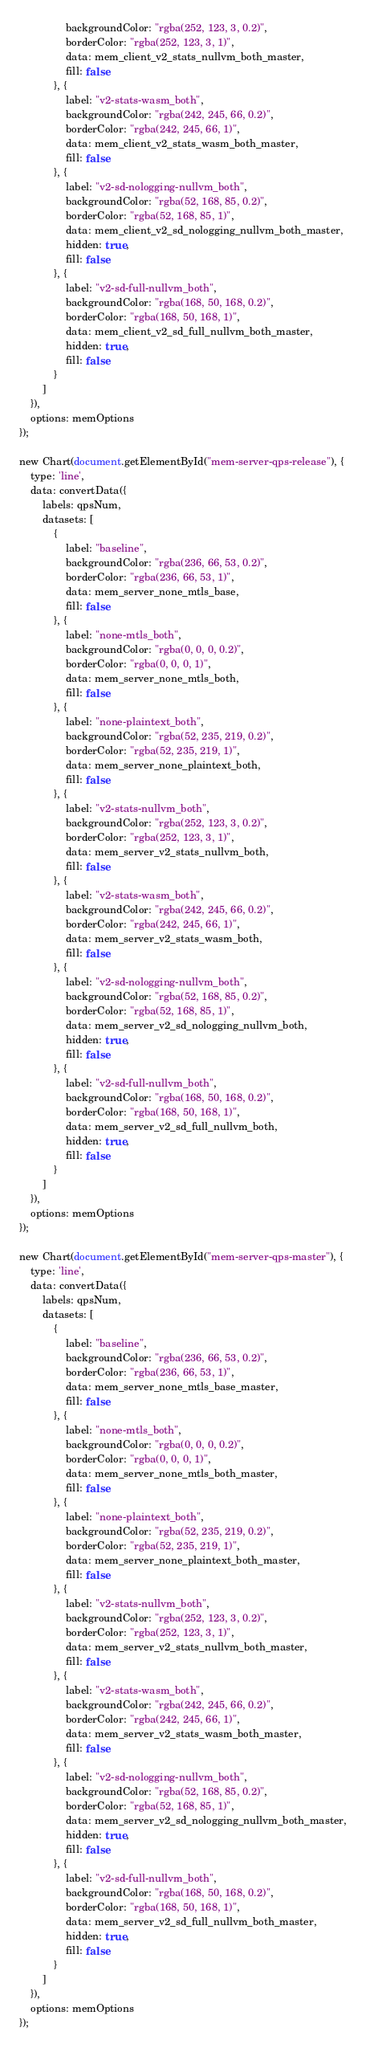<code> <loc_0><loc_0><loc_500><loc_500><_JavaScript_>                backgroundColor: "rgba(252, 123, 3, 0.2)",
                borderColor: "rgba(252, 123, 3, 1)",
                data: mem_client_v2_stats_nullvm_both_master,
                fill: false
            }, {
                label: "v2-stats-wasm_both",
                backgroundColor: "rgba(242, 245, 66, 0.2)",
                borderColor: "rgba(242, 245, 66, 1)",
                data: mem_client_v2_stats_wasm_both_master,
                fill: false
            }, {
                label: "v2-sd-nologging-nullvm_both",
                backgroundColor: "rgba(52, 168, 85, 0.2)",
                borderColor: "rgba(52, 168, 85, 1)",
                data: mem_client_v2_sd_nologging_nullvm_both_master,
                hidden: true,
                fill: false
            }, {
                label: "v2-sd-full-nullvm_both",
                backgroundColor: "rgba(168, 50, 168, 0.2)",
                borderColor: "rgba(168, 50, 168, 1)",
                data: mem_client_v2_sd_full_nullvm_both_master,
                hidden: true,
                fill: false
            }
        ]
    }),
    options: memOptions
});

new Chart(document.getElementById("mem-server-qps-release"), {
    type: 'line',
    data: convertData({
        labels: qpsNum,
        datasets: [
            {
                label: "baseline",
                backgroundColor: "rgba(236, 66, 53, 0.2)",
                borderColor: "rgba(236, 66, 53, 1)",
                data: mem_server_none_mtls_base,
                fill: false
            }, {
                label: "none-mtls_both",
                backgroundColor: "rgba(0, 0, 0, 0.2)",
                borderColor: "rgba(0, 0, 0, 1)",
                data: mem_server_none_mtls_both,
                fill: false
            }, {
                label: "none-plaintext_both",
                backgroundColor: "rgba(52, 235, 219, 0.2)",
                borderColor: "rgba(52, 235, 219, 1)",
                data: mem_server_none_plaintext_both,
                fill: false
            }, {
                label: "v2-stats-nullvm_both",
                backgroundColor: "rgba(252, 123, 3, 0.2)",
                borderColor: "rgba(252, 123, 3, 1)",
                data: mem_server_v2_stats_nullvm_both,
                fill: false
            }, {
                label: "v2-stats-wasm_both",
                backgroundColor: "rgba(242, 245, 66, 0.2)",
                borderColor: "rgba(242, 245, 66, 1)",
                data: mem_server_v2_stats_wasm_both,
                fill: false
            }, {
                label: "v2-sd-nologging-nullvm_both",
                backgroundColor: "rgba(52, 168, 85, 0.2)",
                borderColor: "rgba(52, 168, 85, 1)",
                data: mem_server_v2_sd_nologging_nullvm_both,
                hidden: true,
                fill: false
            }, {
                label: "v2-sd-full-nullvm_both",
                backgroundColor: "rgba(168, 50, 168, 0.2)",
                borderColor: "rgba(168, 50, 168, 1)",
                data: mem_server_v2_sd_full_nullvm_both,
                hidden: true,
                fill: false
            }
        ]
    }),
    options: memOptions
});

new Chart(document.getElementById("mem-server-qps-master"), {
    type: 'line',
    data: convertData({
        labels: qpsNum,
        datasets: [
            {
                label: "baseline",
                backgroundColor: "rgba(236, 66, 53, 0.2)",
                borderColor: "rgba(236, 66, 53, 1)",
                data: mem_server_none_mtls_base_master,
                fill: false
            }, {
                label: "none-mtls_both",
                backgroundColor: "rgba(0, 0, 0, 0.2)",
                borderColor: "rgba(0, 0, 0, 1)",
                data: mem_server_none_mtls_both_master,
                fill: false
            }, {
                label: "none-plaintext_both",
                backgroundColor: "rgba(52, 235, 219, 0.2)",
                borderColor: "rgba(52, 235, 219, 1)",
                data: mem_server_none_plaintext_both_master,
                fill: false
            }, {
                label: "v2-stats-nullvm_both",
                backgroundColor: "rgba(252, 123, 3, 0.2)",
                borderColor: "rgba(252, 123, 3, 1)",
                data: mem_server_v2_stats_nullvm_both_master,
                fill: false
            }, {
                label: "v2-stats-wasm_both",
                backgroundColor: "rgba(242, 245, 66, 0.2)",
                borderColor: "rgba(242, 245, 66, 1)",
                data: mem_server_v2_stats_wasm_both_master,
                fill: false
            }, {
                label: "v2-sd-nologging-nullvm_both",
                backgroundColor: "rgba(52, 168, 85, 0.2)",
                borderColor: "rgba(52, 168, 85, 1)",
                data: mem_server_v2_sd_nologging_nullvm_both_master,
                hidden: true,
                fill: false
            }, {
                label: "v2-sd-full-nullvm_both",
                backgroundColor: "rgba(168, 50, 168, 0.2)",
                borderColor: "rgba(168, 50, 168, 1)",
                data: mem_server_v2_sd_full_nullvm_both_master,
                hidden: true,
                fill: false
            }
        ]
    }),
    options: memOptions
});</code> 